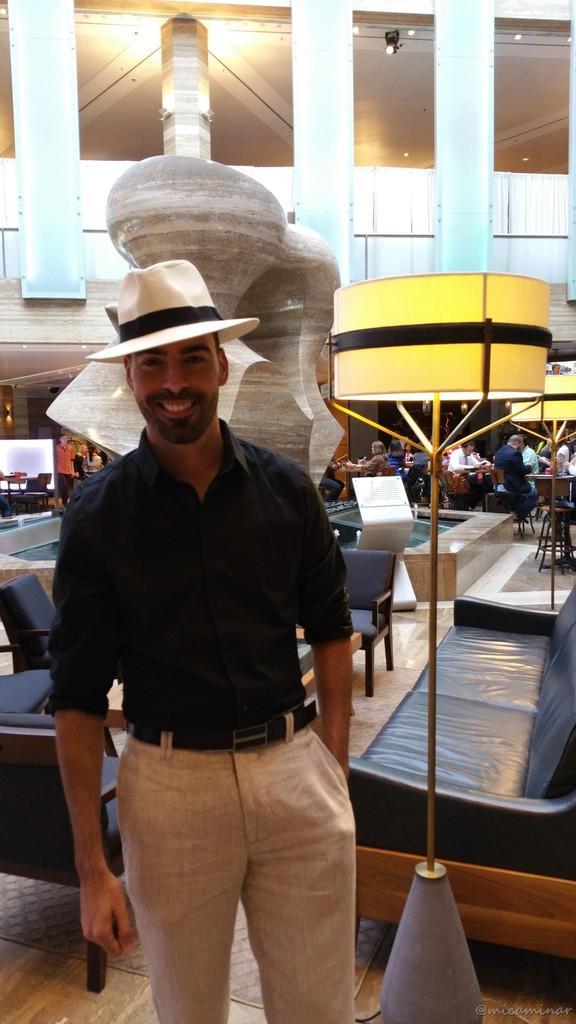Please provide a concise description of this image. Here we can see that a person is standing and smiling, and at back there is sofa, and here is the lamp, and there are lights, and here the group of people are sitting on the chair. 